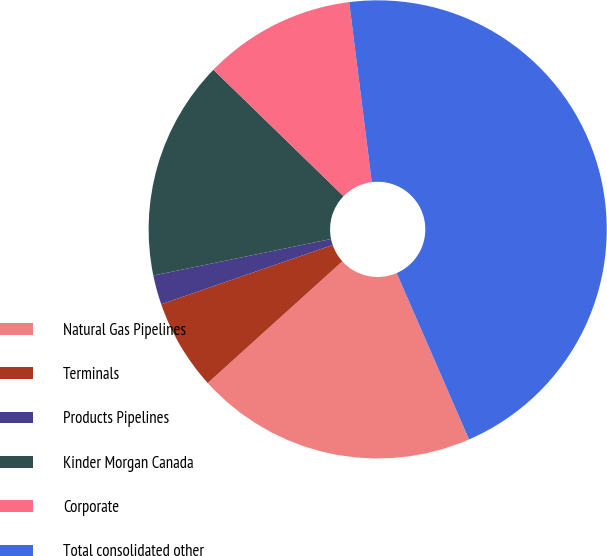Convert chart to OTSL. <chart><loc_0><loc_0><loc_500><loc_500><pie_chart><fcel>Natural Gas Pipelines<fcel>Terminals<fcel>Products Pipelines<fcel>Kinder Morgan Canada<fcel>Corporate<fcel>Total consolidated other<nl><fcel>19.83%<fcel>6.4%<fcel>2.07%<fcel>15.5%<fcel>10.74%<fcel>45.45%<nl></chart> 